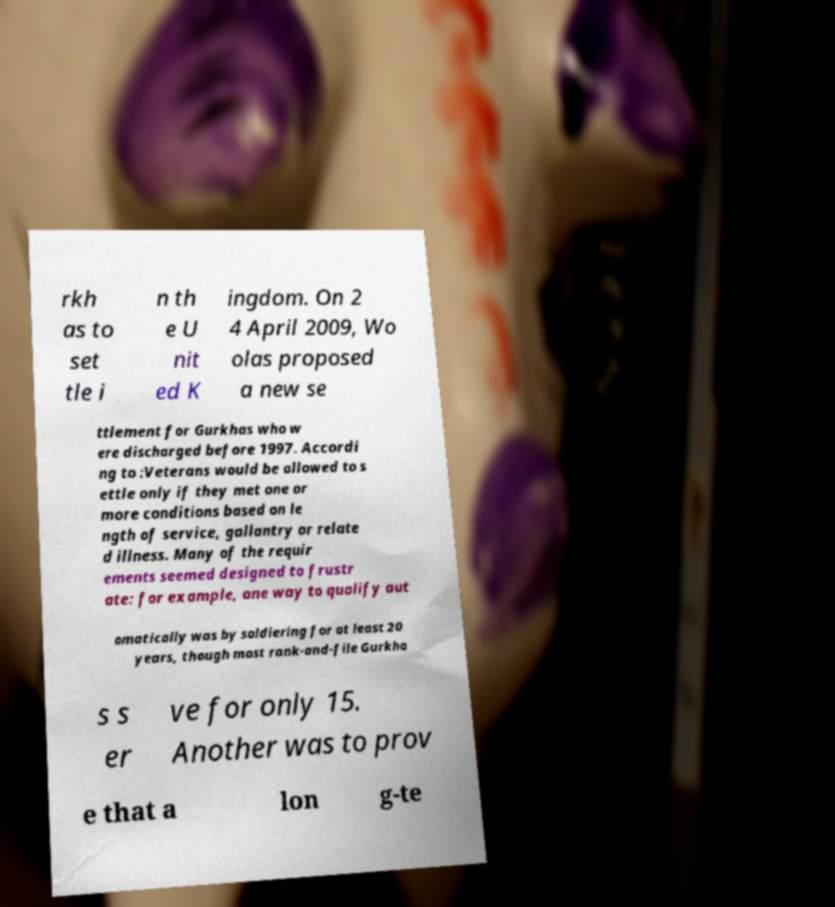Please identify and transcribe the text found in this image. rkh as to set tle i n th e U nit ed K ingdom. On 2 4 April 2009, Wo olas proposed a new se ttlement for Gurkhas who w ere discharged before 1997. Accordi ng to :Veterans would be allowed to s ettle only if they met one or more conditions based on le ngth of service, gallantry or relate d illness. Many of the requir ements seemed designed to frustr ate: for example, one way to qualify aut omatically was by soldiering for at least 20 years, though most rank-and-file Gurkha s s er ve for only 15. Another was to prov e that a lon g-te 